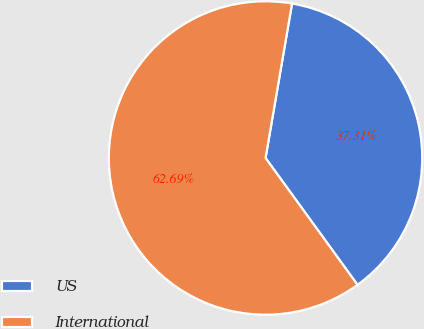Convert chart to OTSL. <chart><loc_0><loc_0><loc_500><loc_500><pie_chart><fcel>US<fcel>International<nl><fcel>37.31%<fcel>62.69%<nl></chart> 